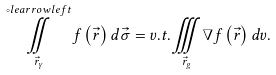<formula> <loc_0><loc_0><loc_500><loc_500>\overset { \circ l e a r r o w l e f t } { \underset { \vec { r } _ { \gamma } } { \iint } } f \left ( \vec { r } \right ) d \vec { \sigma } = v . t . \underset { \vec { r } _ { g } } { \iiint } \nabla f \left ( \vec { r } \right ) d v .</formula> 